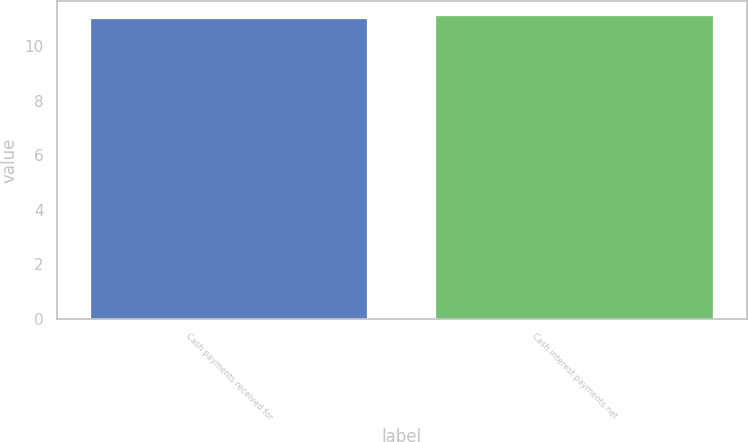Convert chart. <chart><loc_0><loc_0><loc_500><loc_500><bar_chart><fcel>Cash payments received for<fcel>Cash interest payments net<nl><fcel>11<fcel>11.1<nl></chart> 